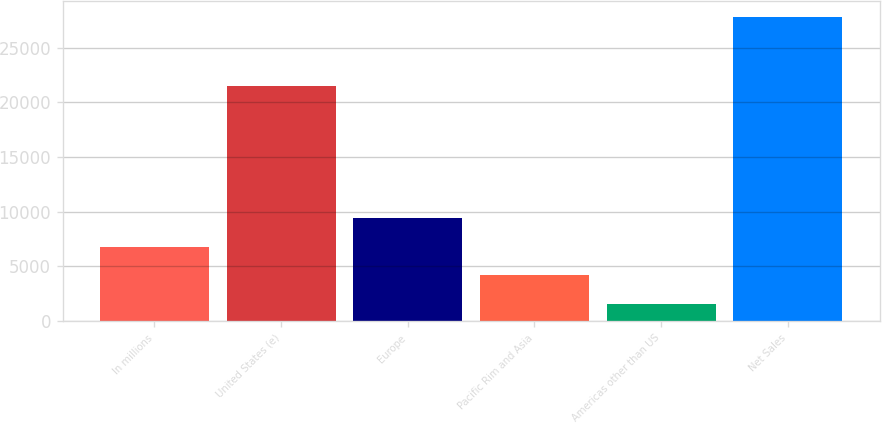Convert chart. <chart><loc_0><loc_0><loc_500><loc_500><bar_chart><fcel>In millions<fcel>United States (e)<fcel>Europe<fcel>Pacific Rim and Asia<fcel>Americas other than US<fcel>Net Sales<nl><fcel>6813.8<fcel>21523<fcel>9441.2<fcel>4186.4<fcel>1559<fcel>27833<nl></chart> 